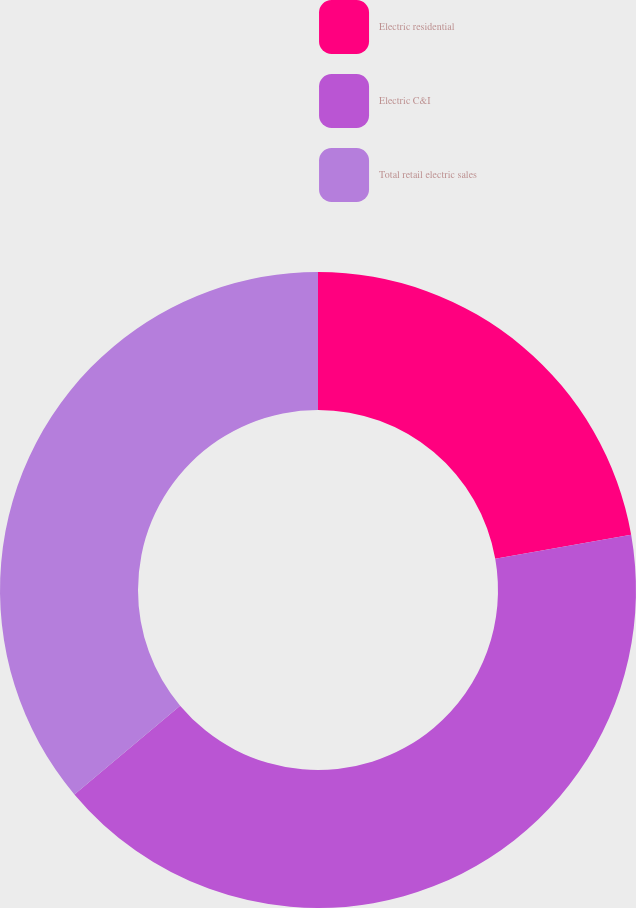<chart> <loc_0><loc_0><loc_500><loc_500><pie_chart><fcel>Electric residential<fcel>Electric C&I<fcel>Total retail electric sales<nl><fcel>22.22%<fcel>41.67%<fcel>36.11%<nl></chart> 